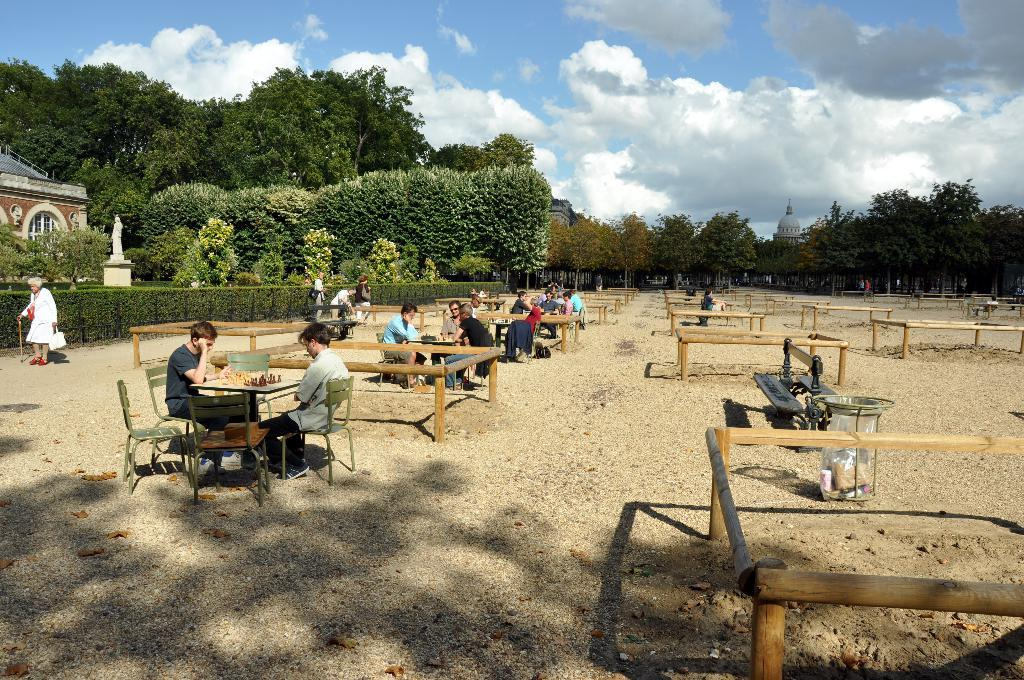What are the people in the image doing? The people in the image are sitting on tables. What is the tables are placed on? The tables are placed on sand. What are the rectangular-sized empty slates used for? The purpose of the rectangular-sized empty slates is not specified in the image. What can be seen in the background of the image? There are houses and trees in the background of the image. What type of metal can be seen on the tail of the animal in the image? There are no animals or tails present in the image. Can you hear the baby crying in the image? There is no sound or indication of a baby crying in the image. 